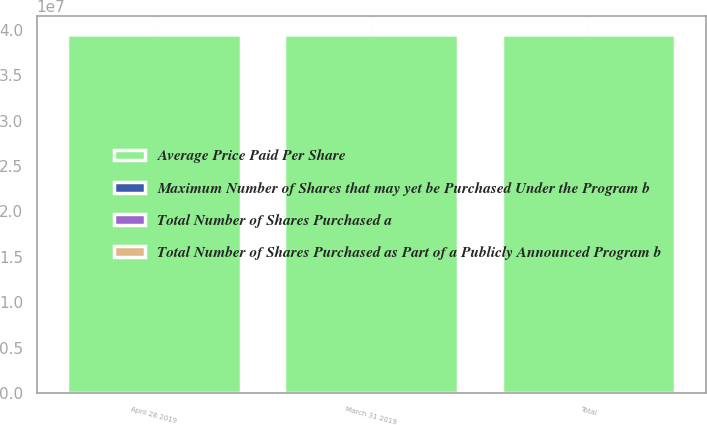Convert chart. <chart><loc_0><loc_0><loc_500><loc_500><stacked_bar_chart><ecel><fcel>March 31 2019<fcel>April 28 2019<fcel>Total<nl><fcel>Total Number of Shares Purchased as Part of a Publicly Announced Program b<fcel>250<fcel>8032<fcel>8282<nl><fcel>Maximum Number of Shares that may yet be Purchased Under the Program b<fcel>47.22<fcel>50.99<fcel>50.88<nl><fcel>Total Number of Shares Purchased a<fcel>250<fcel>8032<fcel>8282<nl><fcel>Average Price Paid Per Share<fcel>3.94986e+07<fcel>3.94906e+07<fcel>3.94906e+07<nl></chart> 